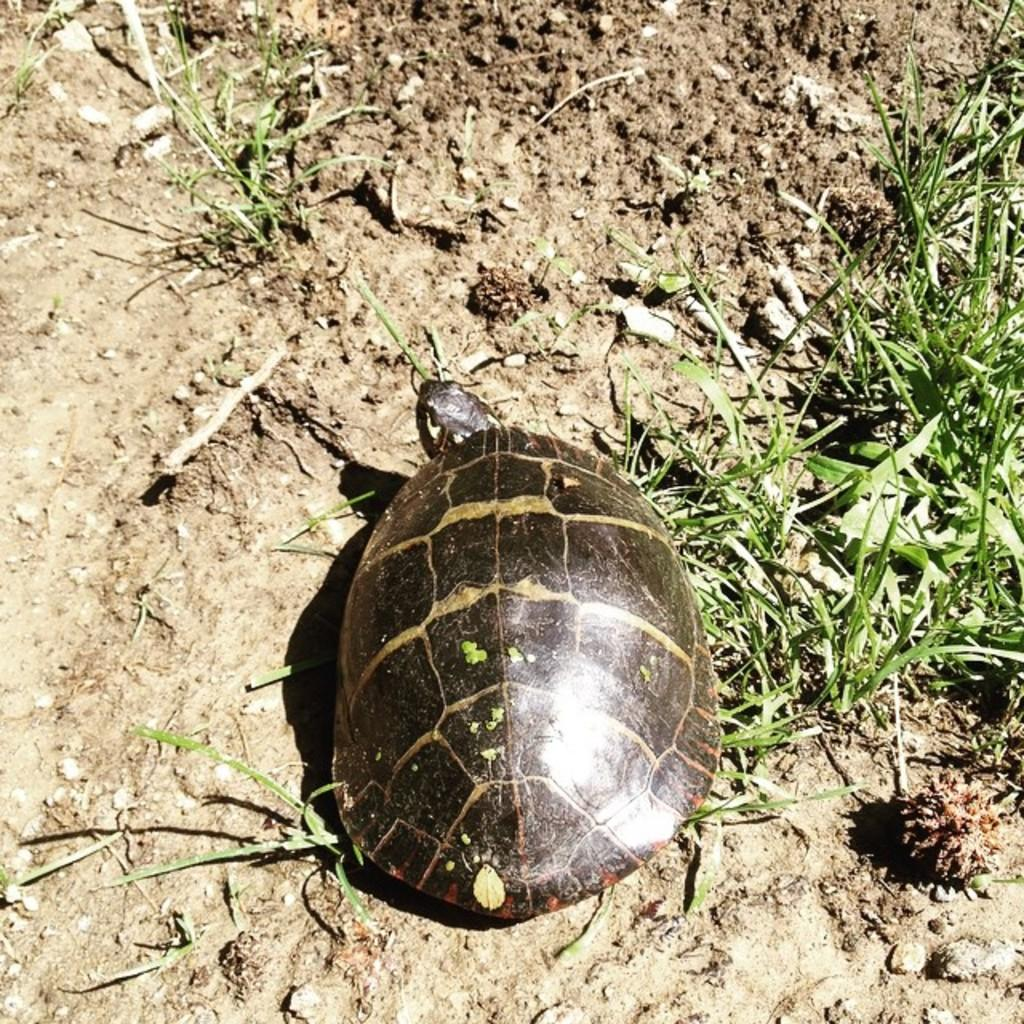What animal is present in the image? There is a tortoise in the image. Where is the tortoise located? The tortoise is on the ground. What type of vegetation is visible around the tortoise? There is grass around the tortoise. What type of jewel is the tortoise wearing on its head in the image? There is no jewel present on the tortoise's head in the image. 